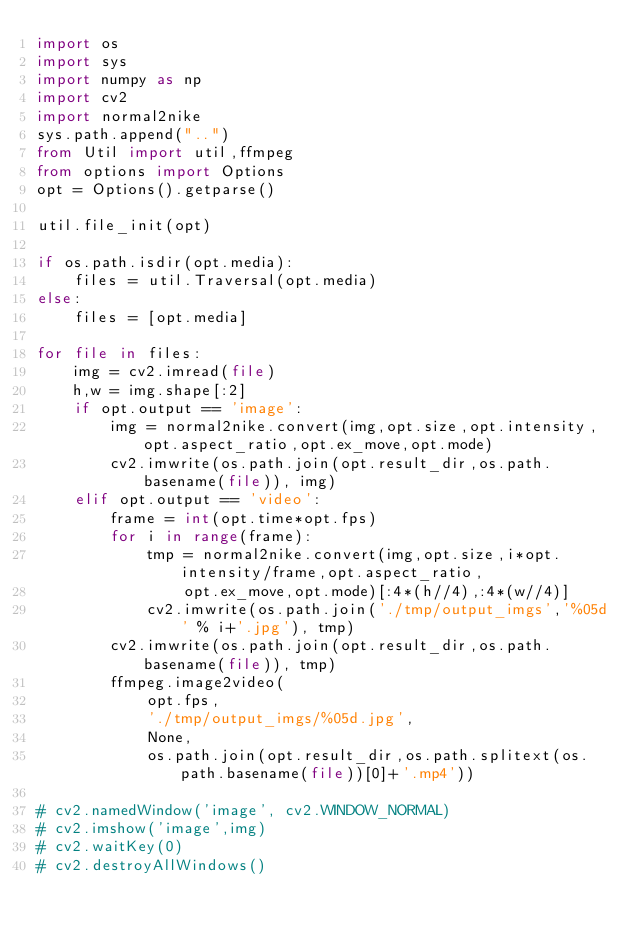<code> <loc_0><loc_0><loc_500><loc_500><_Python_>import os
import sys
import numpy as np
import cv2
import normal2nike
sys.path.append("..")
from Util import util,ffmpeg
from options import Options
opt = Options().getparse()

util.file_init(opt)

if os.path.isdir(opt.media):
    files = util.Traversal(opt.media)
else:
    files = [opt.media]

for file in files:
    img = cv2.imread(file)
    h,w = img.shape[:2]
    if opt.output == 'image':
        img = normal2nike.convert(img,opt.size,opt.intensity,opt.aspect_ratio,opt.ex_move,opt.mode)
        cv2.imwrite(os.path.join(opt.result_dir,os.path.basename(file)), img)
    elif opt.output == 'video':
        frame = int(opt.time*opt.fps)
        for i in range(frame):
            tmp = normal2nike.convert(img,opt.size,i*opt.intensity/frame,opt.aspect_ratio,
                opt.ex_move,opt.mode)[:4*(h//4),:4*(w//4)]
            cv2.imwrite(os.path.join('./tmp/output_imgs','%05d' % i+'.jpg'), tmp)
        cv2.imwrite(os.path.join(opt.result_dir,os.path.basename(file)), tmp)
        ffmpeg.image2video(
            opt.fps,
            './tmp/output_imgs/%05d.jpg',
            None,
            os.path.join(opt.result_dir,os.path.splitext(os.path.basename(file))[0]+'.mp4'))

# cv2.namedWindow('image', cv2.WINDOW_NORMAL)
# cv2.imshow('image',img)
# cv2.waitKey(0)
# cv2.destroyAllWindows()</code> 